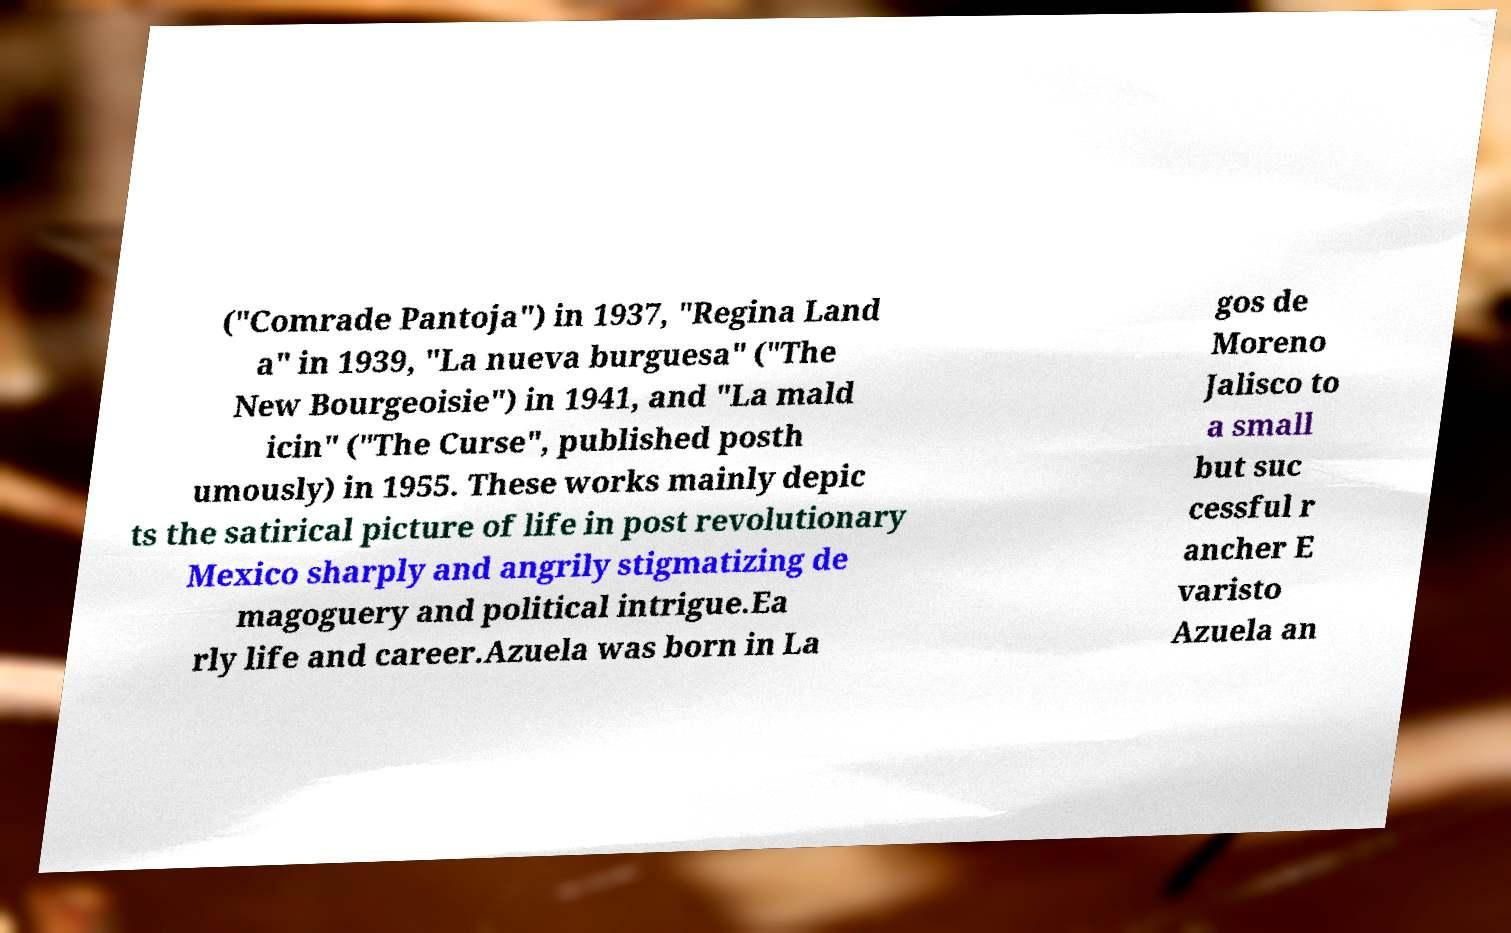Could you assist in decoding the text presented in this image and type it out clearly? ("Comrade Pantoja") in 1937, "Regina Land a" in 1939, "La nueva burguesa" ("The New Bourgeoisie") in 1941, and "La mald icin" ("The Curse", published posth umously) in 1955. These works mainly depic ts the satirical picture of life in post revolutionary Mexico sharply and angrily stigmatizing de magoguery and political intrigue.Ea rly life and career.Azuela was born in La gos de Moreno Jalisco to a small but suc cessful r ancher E varisto Azuela an 